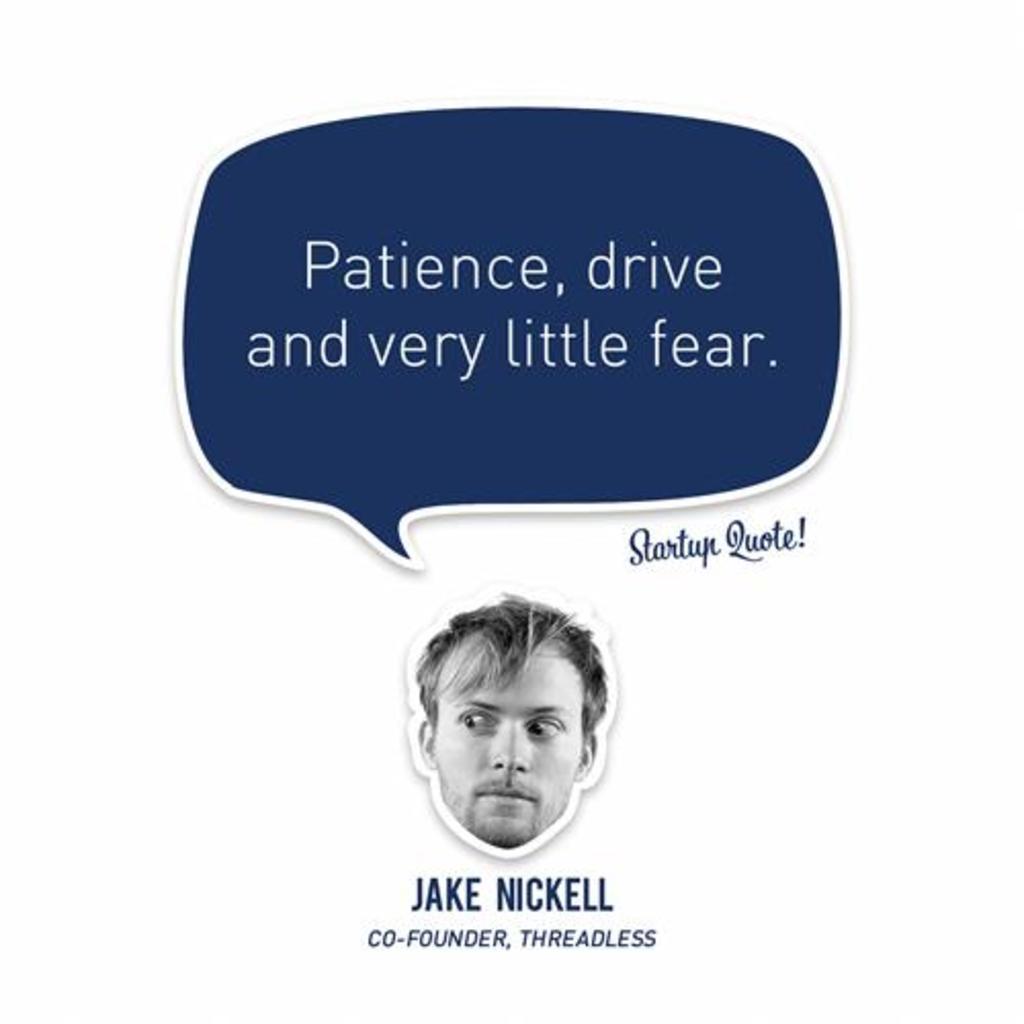In one or two sentences, can you explain what this image depicts? In the middle of the picture, we see the face of a man. I think it is a sticker. At the bottom of the picture, we see some text written in blue color. At the top of the picture, we see a blue color rectangular box in blue color and we see some text written in white color. In the background, it is white in color. 